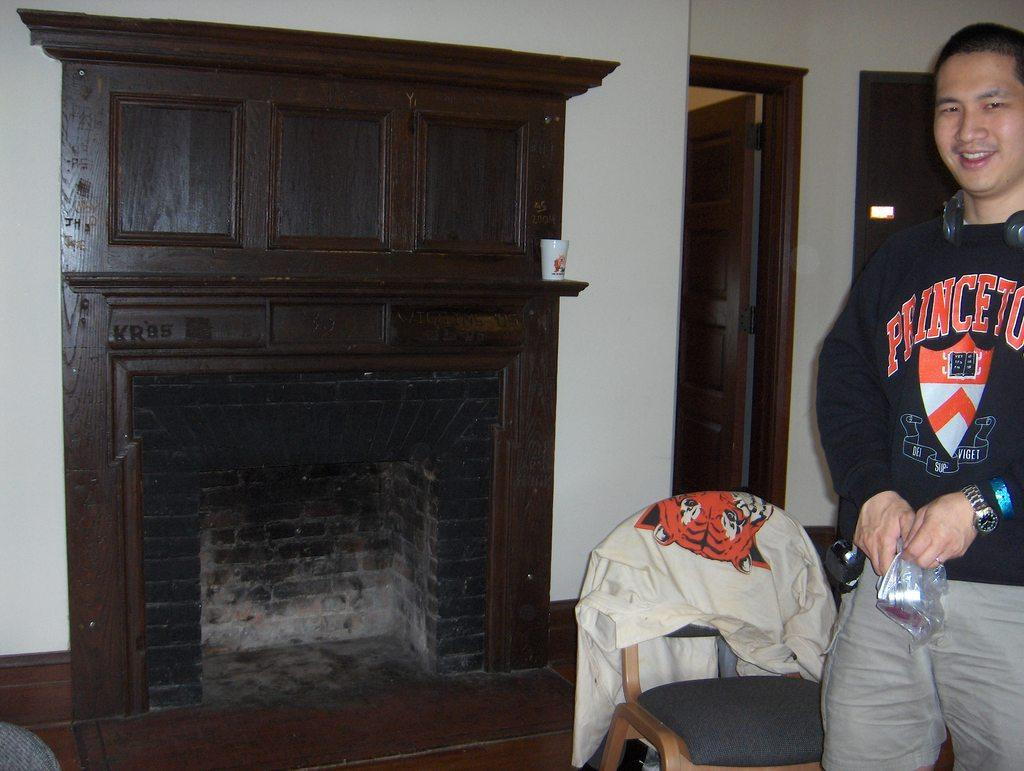Provide a one-sentence caption for the provided image. Young man wearing a Princeton shirt standing next to a old fire place. 